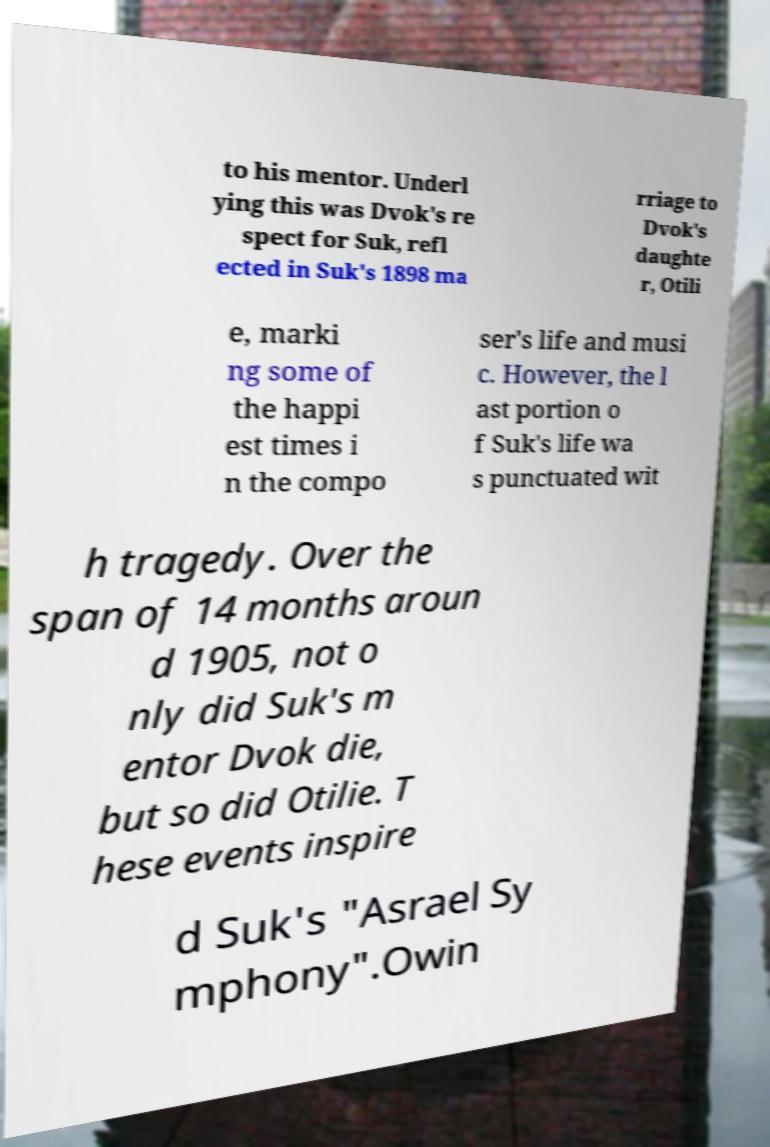I need the written content from this picture converted into text. Can you do that? to his mentor. Underl ying this was Dvok's re spect for Suk, refl ected in Suk's 1898 ma rriage to Dvok's daughte r, Otili e, marki ng some of the happi est times i n the compo ser's life and musi c. However, the l ast portion o f Suk's life wa s punctuated wit h tragedy. Over the span of 14 months aroun d 1905, not o nly did Suk's m entor Dvok die, but so did Otilie. T hese events inspire d Suk's "Asrael Sy mphony".Owin 